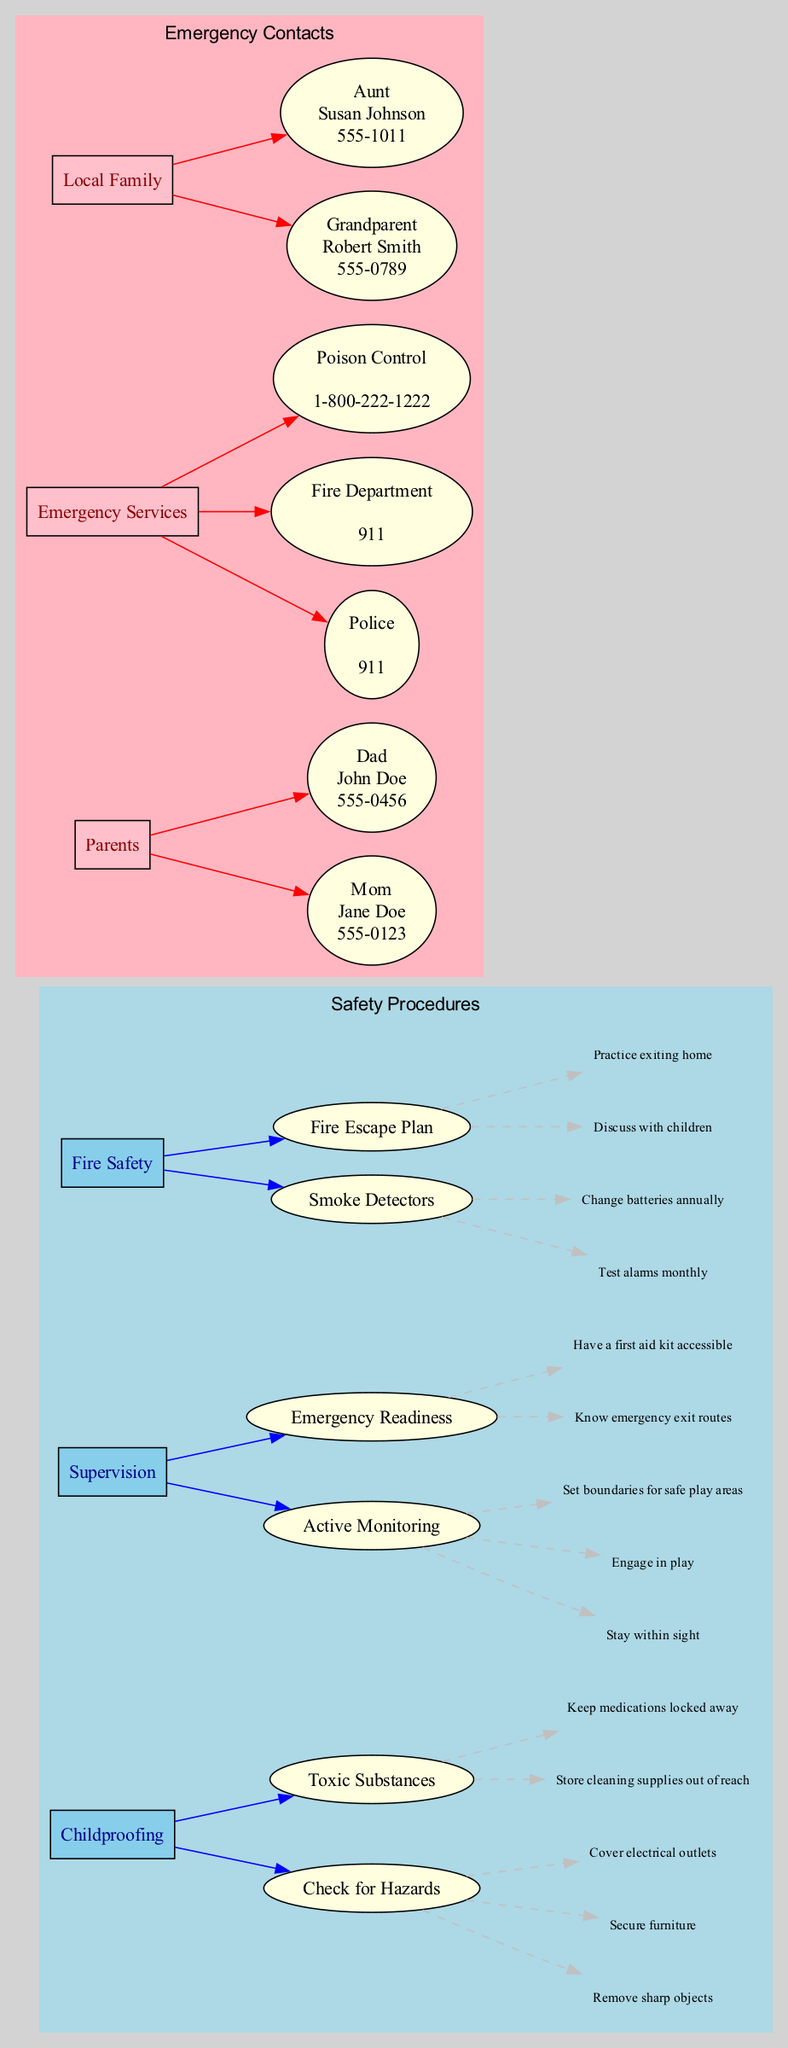What are the three main categories of safety procedures? The diagram includes three main categories under safety procedures: Childproofing, Supervision, and Fire Safety. Each of these categories contains specific subcategories.
Answer: Childproofing, Supervision, Fire Safety How many emergency contact types are listed in the diagram? The diagram has three main types of emergency contacts: Parents, Emergency Services, and Local Family. Therefore, the total count of emergency contact types is three.
Answer: 3 Which number should I dial for poison control? The diagram specifies that the contact number for Poison Control is 1-800-222-1222, highlighting that this is a crucial emergency number in case of poisoning incidents.
Answer: 1-800-222-1222 What is one fire safety procedure related to smoke detectors? Among the listed procedures for fire safety, one specific procedure related to smoke detectors is to "Test alarms monthly." This emphasizes the importance of maintaining functional smoke detectors in any household.
Answer: Test alarms monthly What should be done with cleaning supplies for childproofing? The diagram points out that cleaning supplies should be "Stored out of reach" as part of the toxic substances under childproofing, indicating a necessary safety measure to prevent children from accessing harmful chemicals.
Answer: Store cleaning supplies out of reach How often should batteries in smoke detectors be changed? According to the diagram, the recommended frequency for changing batteries in smoke detectors is "annually." This suggests routine maintenance to ensure the alarms are always operational.
Answer: Annually What is the name of the children's grandparent on the emergency contact list? The diagram lists the grandparent's name on the emergency contact list as Robert Smith, making him a key point of contact should emergencies arise while babysitting.
Answer: Robert Smith Which category includes "Engage in play" as a procedure? The procedure "Engage in play" is found under the Supervision category, specifically in the subcategory of Active Monitoring, indicating the importance of engagement in child supervision.
Answer: Supervision How many procedures are listed under the 'Childproofing' category? Under the Childproofing category, there are two major procedures: Check for Hazards and Toxic Substances, meaning there are two distinct procedures listed within that category.
Answer: 2 